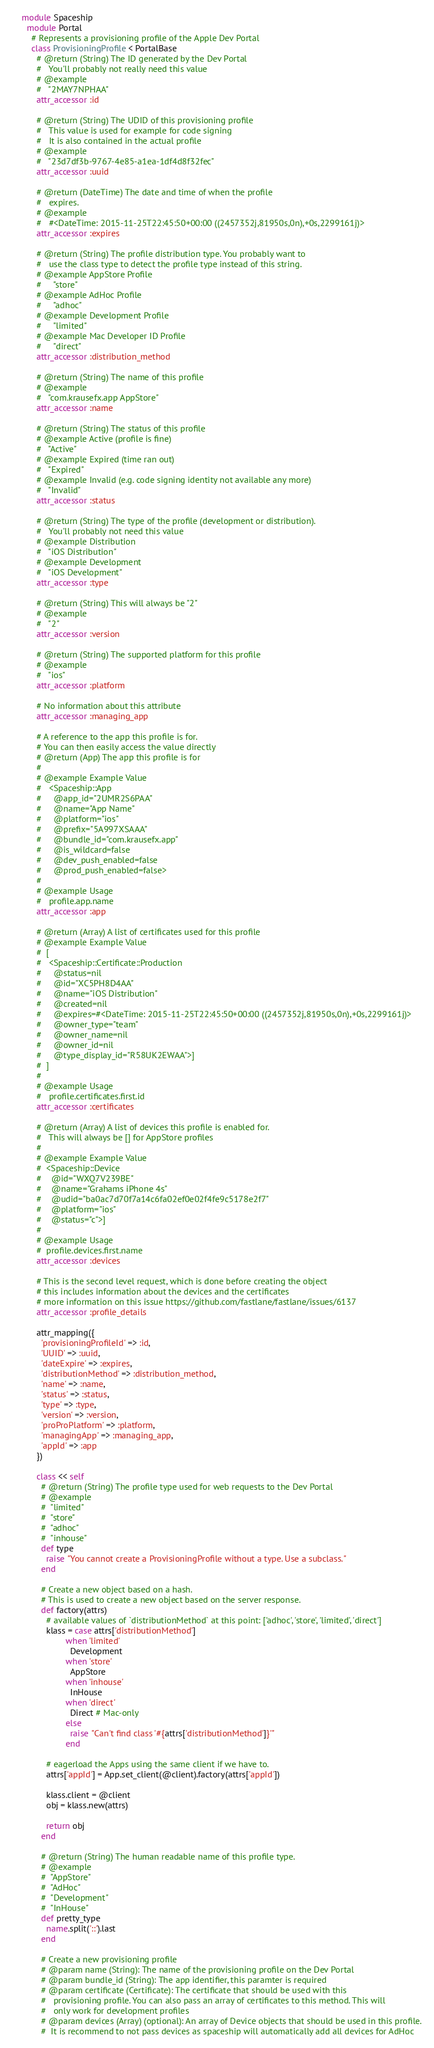Convert code to text. <code><loc_0><loc_0><loc_500><loc_500><_Ruby_>module Spaceship
  module Portal
    # Represents a provisioning profile of the Apple Dev Portal
    class ProvisioningProfile < PortalBase
      # @return (String) The ID generated by the Dev Portal
      #   You'll probably not really need this value
      # @example
      #   "2MAY7NPHAA"
      attr_accessor :id

      # @return (String) The UDID of this provisioning profile
      #   This value is used for example for code signing
      #   It is also contained in the actual profile
      # @example
      #   "23d7df3b-9767-4e85-a1ea-1df4d8f32fec"
      attr_accessor :uuid

      # @return (DateTime) The date and time of when the profile
      #   expires.
      # @example
      #   #<DateTime: 2015-11-25T22:45:50+00:00 ((2457352j,81950s,0n),+0s,2299161j)>
      attr_accessor :expires

      # @return (String) The profile distribution type. You probably want to
      #   use the class type to detect the profile type instead of this string.
      # @example AppStore Profile
      #     "store"
      # @example AdHoc Profile
      #     "adhoc"
      # @example Development Profile
      #     "limited"
      # @example Mac Developer ID Profile
      #     "direct"
      attr_accessor :distribution_method

      # @return (String) The name of this profile
      # @example
      #   "com.krausefx.app AppStore"
      attr_accessor :name

      # @return (String) The status of this profile
      # @example Active (profile is fine)
      #   "Active"
      # @example Expired (time ran out)
      #   "Expired"
      # @example Invalid (e.g. code signing identity not available any more)
      #   "Invalid"
      attr_accessor :status

      # @return (String) The type of the profile (development or distribution).
      #   You'll probably not need this value
      # @example Distribution
      #   "iOS Distribution"
      # @example Development
      #   "iOS Development"
      attr_accessor :type

      # @return (String) This will always be "2"
      # @example
      #   "2"
      attr_accessor :version

      # @return (String) The supported platform for this profile
      # @example
      #   "ios"
      attr_accessor :platform

      # No information about this attribute
      attr_accessor :managing_app

      # A reference to the app this profile is for.
      # You can then easily access the value directly
      # @return (App) The app this profile is for
      #
      # @example Example Value
      #   <Spaceship::App
      #     @app_id="2UMR2S6PAA"
      #     @name="App Name"
      #     @platform="ios"
      #     @prefix="5A997XSAAA"
      #     @bundle_id="com.krausefx.app"
      #     @is_wildcard=false
      #     @dev_push_enabled=false
      #     @prod_push_enabled=false>
      #
      # @example Usage
      #   profile.app.name
      attr_accessor :app

      # @return (Array) A list of certificates used for this profile
      # @example Example Value
      #  [
      #   <Spaceship::Certificate::Production
      #     @status=nil
      #     @id="XC5PH8D4AA"
      #     @name="iOS Distribution"
      #     @created=nil
      #     @expires=#<DateTime: 2015-11-25T22:45:50+00:00 ((2457352j,81950s,0n),+0s,2299161j)>
      #     @owner_type="team"
      #     @owner_name=nil
      #     @owner_id=nil
      #     @type_display_id="R58UK2EWAA">]
      #  ]
      #
      # @example Usage
      #   profile.certificates.first.id
      attr_accessor :certificates

      # @return (Array) A list of devices this profile is enabled for.
      #   This will always be [] for AppStore profiles
      #
      # @example Example Value
      #  <Spaceship::Device
      #    @id="WXQ7V239BE"
      #    @name="Grahams iPhone 4s"
      #    @udid="ba0ac7d70f7a14c6fa02ef0e02f4fe9c5178e2f7"
      #    @platform="ios"
      #    @status="c">]
      #
      # @example Usage
      #  profile.devices.first.name
      attr_accessor :devices

      # This is the second level request, which is done before creating the object
      # this includes information about the devices and the certificates
      # more information on this issue https://github.com/fastlane/fastlane/issues/6137
      attr_accessor :profile_details

      attr_mapping({
        'provisioningProfileId' => :id,
        'UUID' => :uuid,
        'dateExpire' => :expires,
        'distributionMethod' => :distribution_method,
        'name' => :name,
        'status' => :status,
        'type' => :type,
        'version' => :version,
        'proProPlatform' => :platform,
        'managingApp' => :managing_app,
        'appId' => :app
      })

      class << self
        # @return (String) The profile type used for web requests to the Dev Portal
        # @example
        #  "limited"
        #  "store"
        #  "adhoc"
        #  "inhouse"
        def type
          raise "You cannot create a ProvisioningProfile without a type. Use a subclass."
        end

        # Create a new object based on a hash.
        # This is used to create a new object based on the server response.
        def factory(attrs)
          # available values of `distributionMethod` at this point: ['adhoc', 'store', 'limited', 'direct']
          klass = case attrs['distributionMethod']
                  when 'limited'
                    Development
                  when 'store'
                    AppStore
                  when 'inhouse'
                    InHouse
                  when 'direct'
                    Direct # Mac-only
                  else
                    raise "Can't find class '#{attrs['distributionMethod']}'"
                  end

          # eagerload the Apps using the same client if we have to.
          attrs['appId'] = App.set_client(@client).factory(attrs['appId'])

          klass.client = @client
          obj = klass.new(attrs)

          return obj
        end

        # @return (String) The human readable name of this profile type.
        # @example
        #  "AppStore"
        #  "AdHoc"
        #  "Development"
        #  "InHouse"
        def pretty_type
          name.split('::').last
        end

        # Create a new provisioning profile
        # @param name (String): The name of the provisioning profile on the Dev Portal
        # @param bundle_id (String): The app identifier, this paramter is required
        # @param certificate (Certificate): The certificate that should be used with this
        #   provisioning profile. You can also pass an array of certificates to this method. This will
        #   only work for development profiles
        # @param devices (Array) (optional): An array of Device objects that should be used in this profile.
        #  It is recommend to not pass devices as spaceship will automatically add all devices for AdHoc</code> 